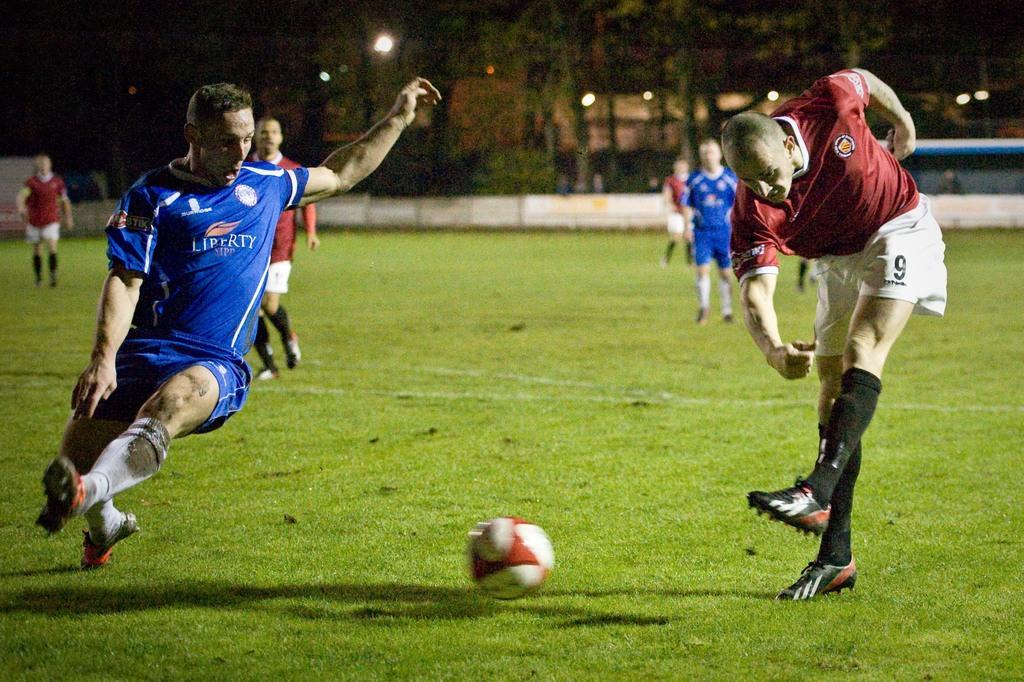What sport are the players engaged in on the ground? The players are playing football on the ground. Where is the football located in the image? There is a football in the middle of the field. What can be seen in the background of the image? There are trees, buildings, and lights in the background of the image. What feature surrounds the field? There is a boundary around the field. Can you provide an example of a place where the players might go to help them improve their skills? The image does not provide information about a specific place where the players might go to help them improve their skills. 